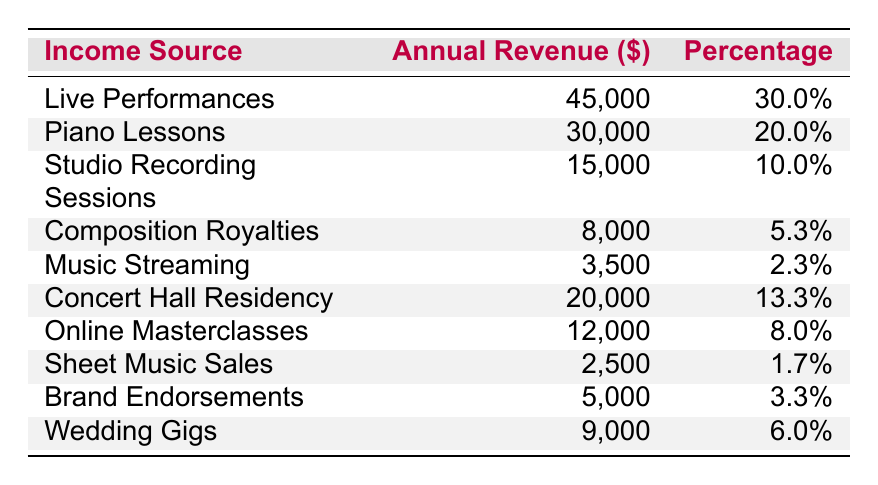What is the annual revenue from live performances? The table shows that the annual revenue from live performances is listed as 45,000 dollars.
Answer: 45,000 What percentage of the total income comes from piano lessons? According to the table, the percentage of total income from piano lessons is 20%.
Answer: 20% What is the total annual revenue from music streaming and sheet music sales combined? The annual revenue for music streaming is 3,500 dollars, and for sheet music sales, it is 2,500 dollars. Adding these gives 3,500 + 2,500 = 6,000 dollars.
Answer: 6,000 Is the annual revenue from composition royalties greater than that from online masterclasses? The table shows that composition royalties generate 8,000 dollars, while online masterclasses generate 12,000 dollars. Since 8,000 is less than 12,000, the statement is false.
Answer: No Which income source has the least percentage of total income? By looking at the percentage column, sheet music sales at 1.7% has the lowest percentage of total income compared to other sources.
Answer: Sheet music sales What is the average annual revenue from all income sources listed? To find the average, add all annual revenues: 45,000 + 30,000 + 15,000 + 8,000 + 3,500 + 20,000 + 12,000 + 2,500 + 5,000 + 9,000 =  145,000. There are 10 sources, so divide 145,000 by 10, resulting in 14,500 dollars.
Answer: 14,500 Which two income sources contribute most to total revenue? The highest revenue sources are live performances at 45,000 dollars and piano lessons at 30,000 dollars. Combined, they produce 45,000 + 30,000 = 75,000 dollars.
Answer: Live performances and piano lessons If the total revenue is 150,000 dollars, how much more does live performances contribute than music streaming? Live performances contribute 45,000 dollars while music streaming contributes 3,500 dollars. The difference is calculated as 45,000 - 3,500 = 41,500 dollars.
Answer: 41,500 What is the revenue generated by wedding gigs as a percentage of total income? The revenue from wedding gigs is 9,000 dollars. To find its percentage share of the total income (150,000 dollars), calculate (9,000 / 150,000) * 100 = 6%.
Answer: 6% What income source contributes roughly one-third of the total revenue? The live performances generate 45,000 dollars, which is approximately 30% of total income (since 30% of 150,000 is about 45,000).
Answer: Live performances What is the difference between the revenue of concert hall residency and the lowest income source? Concert hall residency earns 20,000 dollars, while the lowest income source, sheet music sales, earns 2,500 dollars. The difference is 20,000 - 2,500 = 17,500 dollars.
Answer: 17,500 